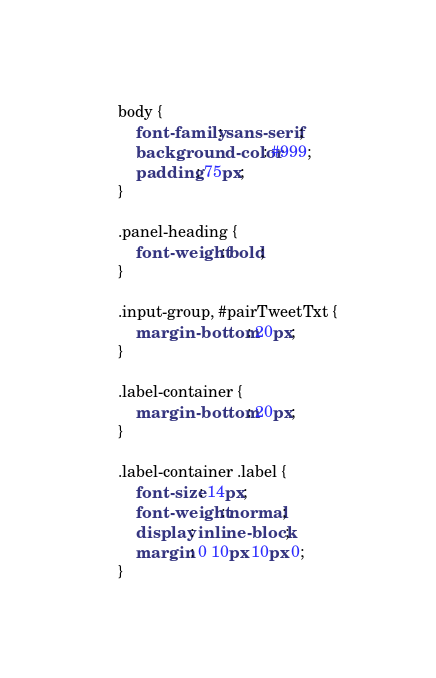<code> <loc_0><loc_0><loc_500><loc_500><_CSS_>body {
	font-family: sans-serif;
	background-color: #999;
	padding: 75px;
}

.panel-heading {
	font-weight: bold;
}

.input-group, #pairTweetTxt {
	margin-bottom: 20px;
}

.label-container {
	margin-bottom: 20px;
}

.label-container .label {
	font-size: 14px;
	font-weight: normal;
	display: inline-block;
	margin: 0 10px 10px 0;
}</code> 